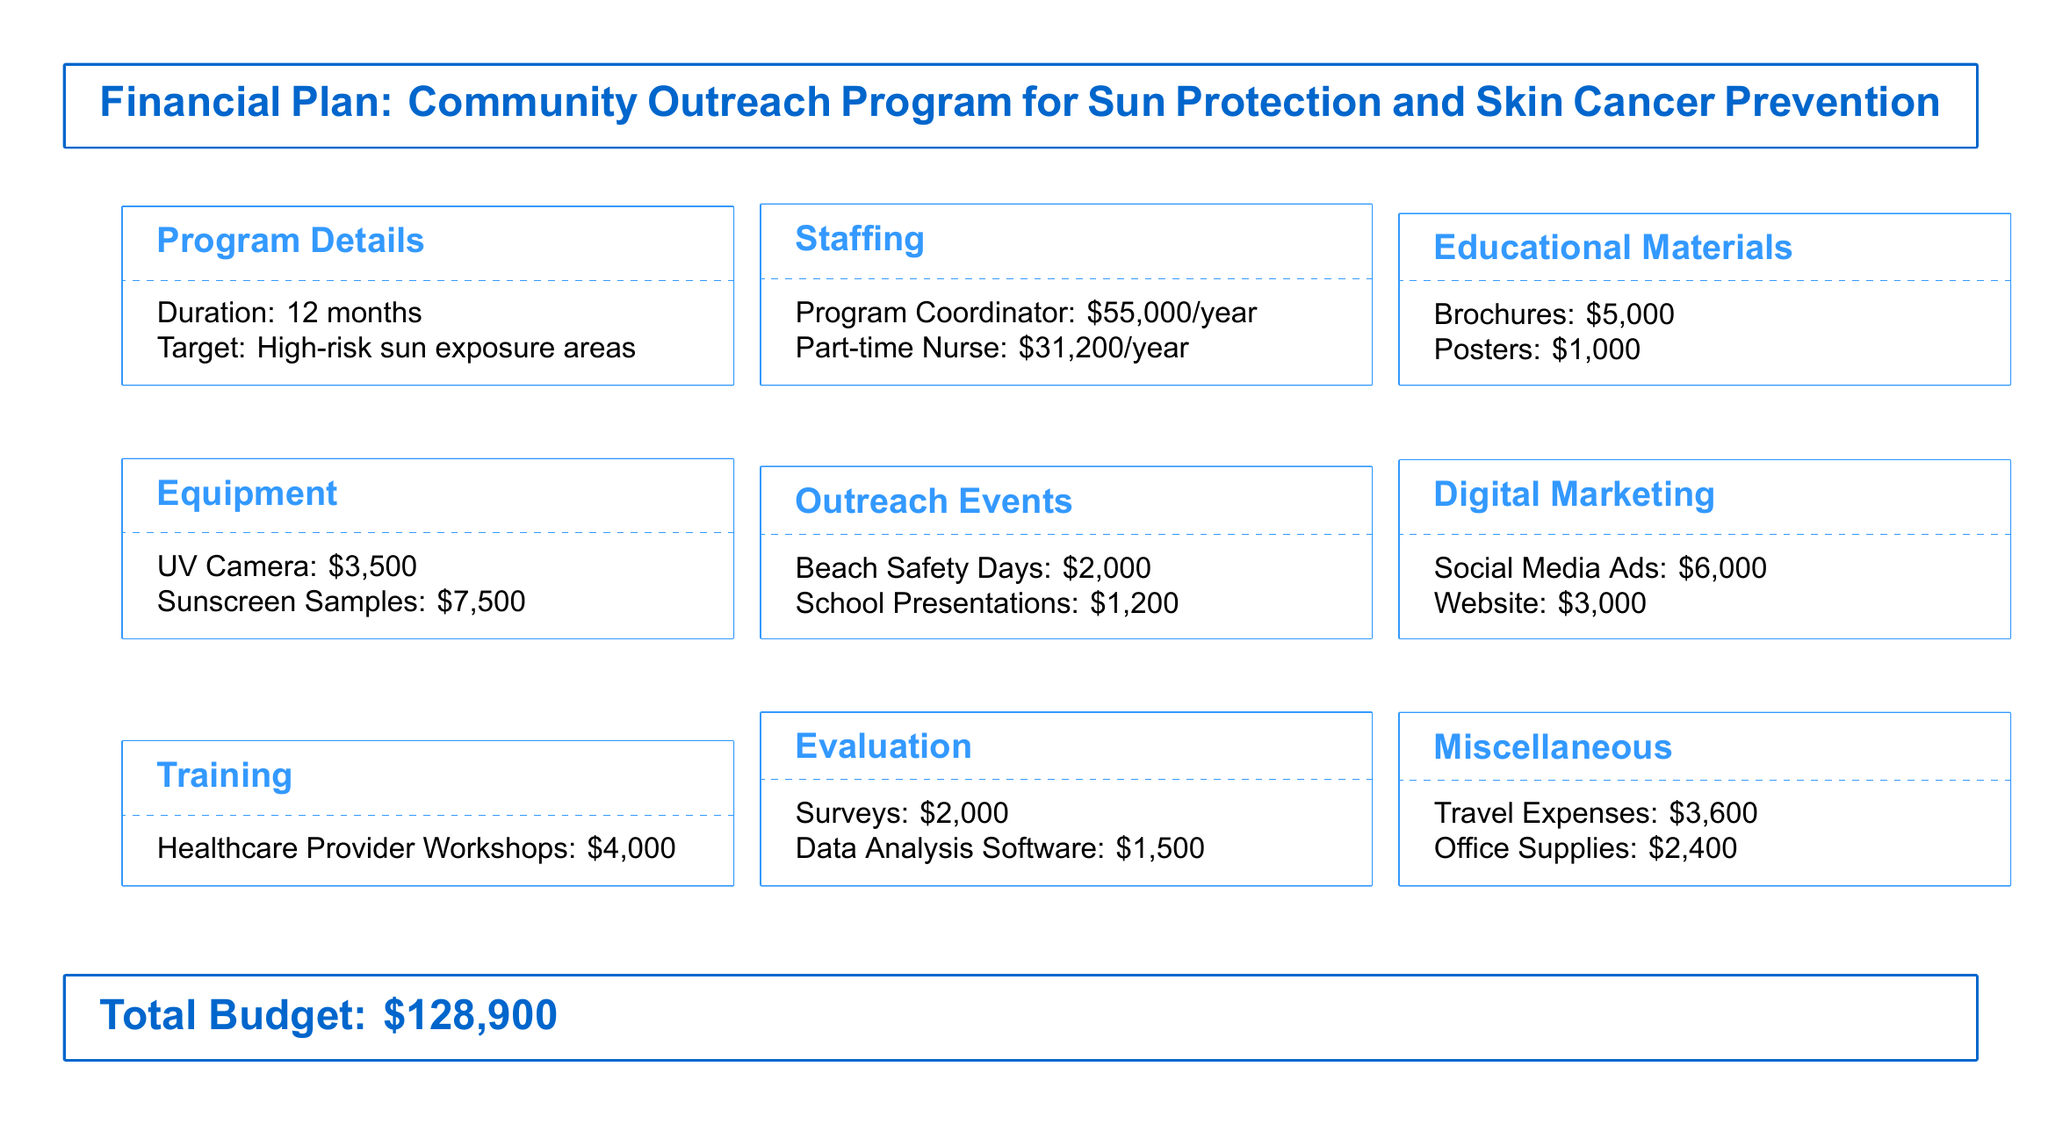What is the target of the program? The document states that the target is high-risk sun exposure areas.
Answer: High-risk sun exposure areas What is the salary of the Program Coordinator? The salary for the Program Coordinator is listed in the Staffing section.
Answer: $55,000/year How much is allocated for brochures? The amount for brochures is specified in the Educational Materials section.
Answer: $5,000 What is the total budget? The total budget is mentioned at the end of the document.
Answer: $128,900 What type of events does the outreach program include? The document specifies the types of events in the Outreach Events section.
Answer: Beach Safety Days, School Presentations What is the cost for healthcare provider workshops? The cost is provided under the Training section of the budget.
Answer: $4,000 How much is allocated for digital marketing? This amount is detailed in the Digital Marketing section of the budget.
Answer: $9,000 What is the cost of the UV camera? The cost is specified in the Equipment section of the document.
Answer: $3,500 What expenses are listed under Miscellaneous? The document lists specific expenses under the Miscellaneous section.
Answer: Travel Expenses, Office Supplies 